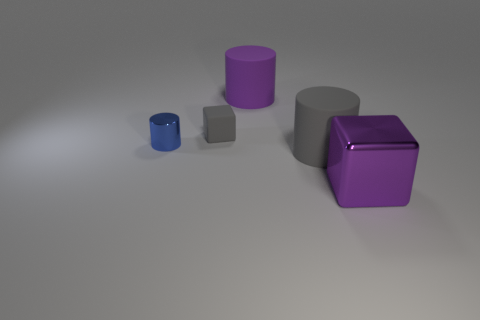Add 3 small blocks. How many objects exist? 8 Subtract all blocks. How many objects are left? 3 Subtract all cubes. Subtract all yellow spheres. How many objects are left? 3 Add 4 small matte blocks. How many small matte blocks are left? 5 Add 3 brown metal cubes. How many brown metal cubes exist? 3 Subtract 0 blue cubes. How many objects are left? 5 